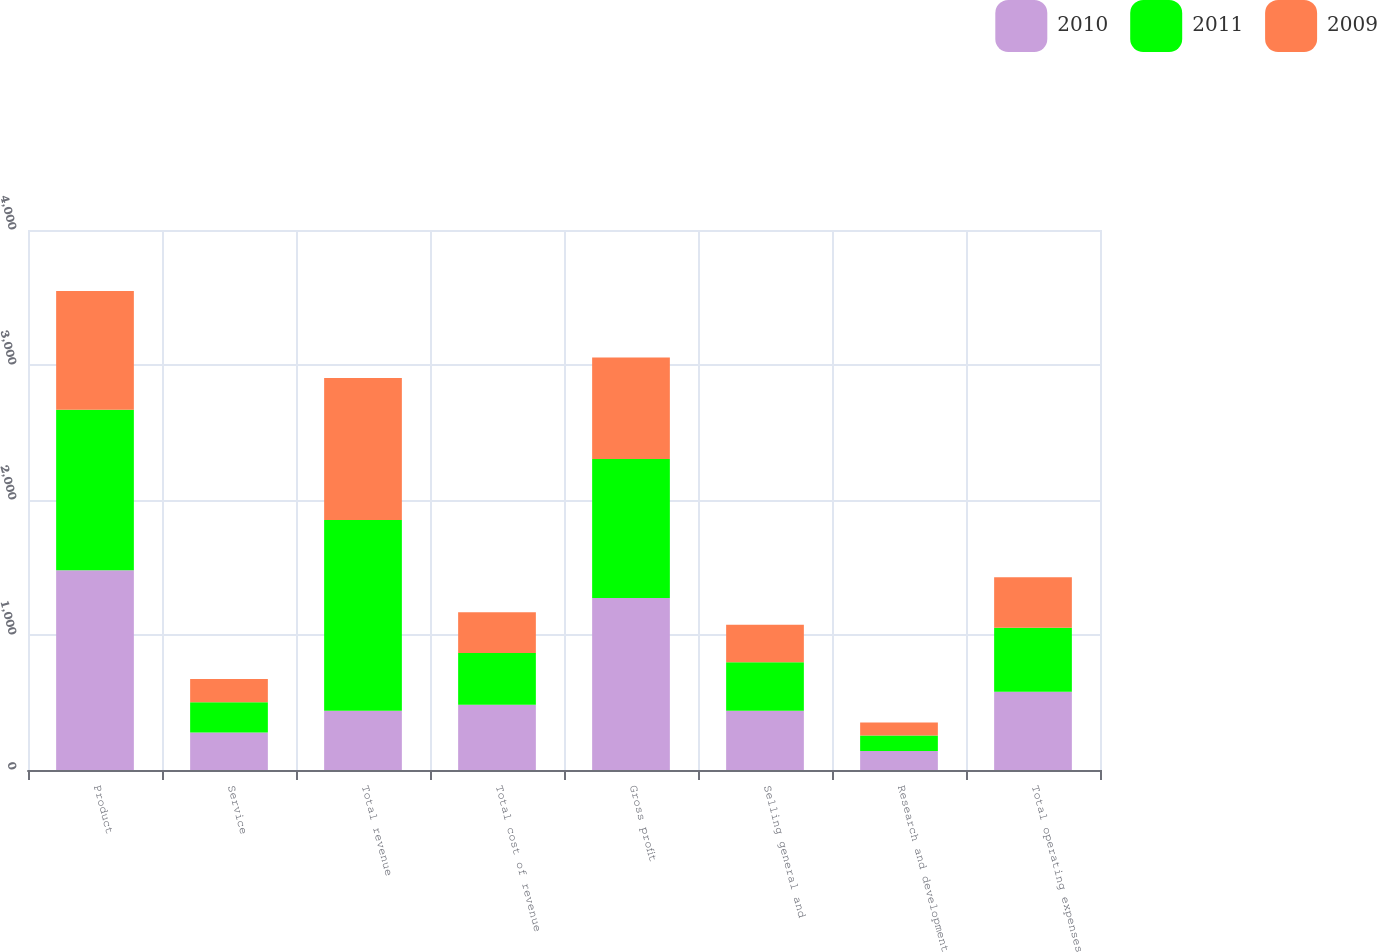Convert chart to OTSL. <chart><loc_0><loc_0><loc_500><loc_500><stacked_bar_chart><ecel><fcel>Product<fcel>Service<fcel>Total revenue<fcel>Total cost of revenue<fcel>Gross profit<fcel>Selling general and<fcel>Research and development<fcel>Total operating expenses<nl><fcel>2010<fcel>1478.9<fcel>278.4<fcel>438.8<fcel>483.5<fcel>1273.8<fcel>438.8<fcel>140.2<fcel>579<nl><fcel>2011<fcel>1189.1<fcel>223.9<fcel>1413<fcel>383<fcel>1030<fcel>358.8<fcel>116<fcel>474.8<nl><fcel>2009<fcel>879.9<fcel>172.3<fcel>1052.2<fcel>301.1<fcel>751.1<fcel>278.6<fcel>95.1<fcel>373.7<nl></chart> 